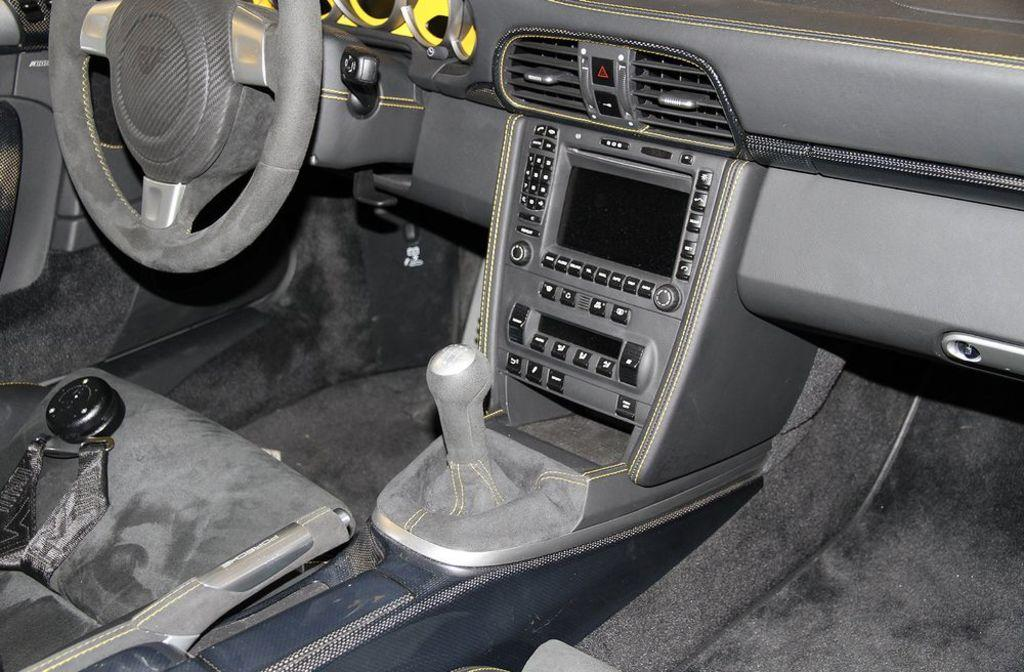What type of environment is depicted in the image? The image shows an inner view of a vehicle. What is the primary control mechanism in the vehicle? There is a steering wheel in the image. How can the driver change the vehicle's speed or direction? There is a gear in the image. What other features are present in the vehicle's interior? There are buttons in the image. Can you see a toothbrush in the image? No, there is no toothbrush present in the image. Is there a river flowing through the vehicle in the image? No, there is no river depicted in the image; it shows the interior of a vehicle. 